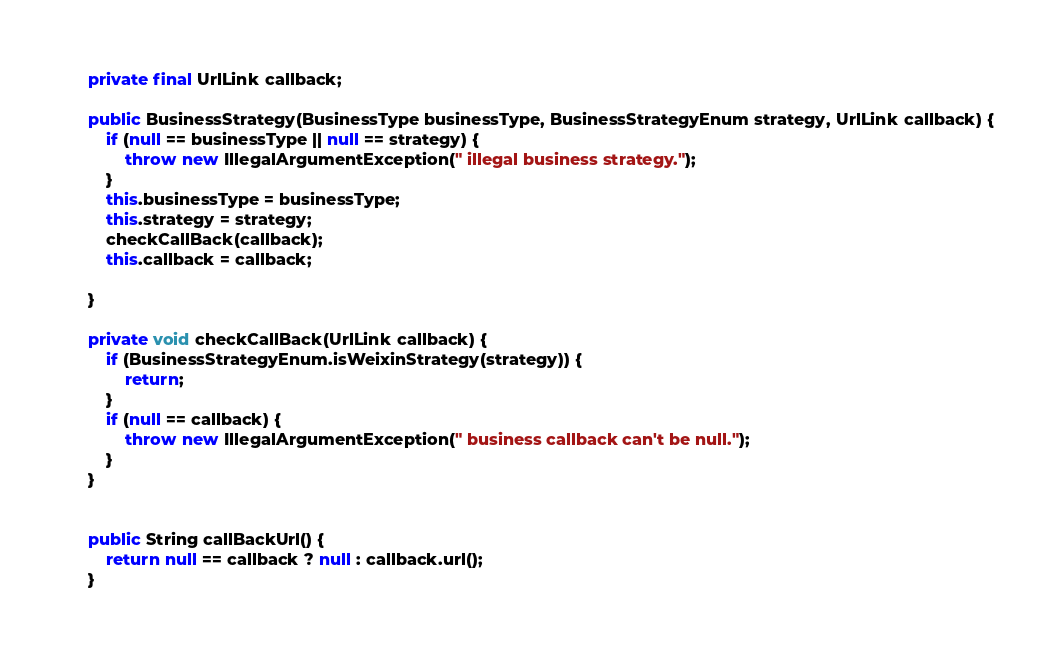<code> <loc_0><loc_0><loc_500><loc_500><_Java_>
    private final UrlLink callback;

    public BusinessStrategy(BusinessType businessType, BusinessStrategyEnum strategy, UrlLink callback) {
        if (null == businessType || null == strategy) {
            throw new IllegalArgumentException(" illegal business strategy.");
        }
        this.businessType = businessType;
        this.strategy = strategy;
        checkCallBack(callback);
        this.callback = callback;

    }

    private void checkCallBack(UrlLink callback) {
        if (BusinessStrategyEnum.isWeixinStrategy(strategy)) {
            return;
        }
        if (null == callback) {
            throw new IllegalArgumentException(" business callback can't be null.");
        }
    }


    public String callBackUrl() {
        return null == callback ? null : callback.url();
    }
</code> 